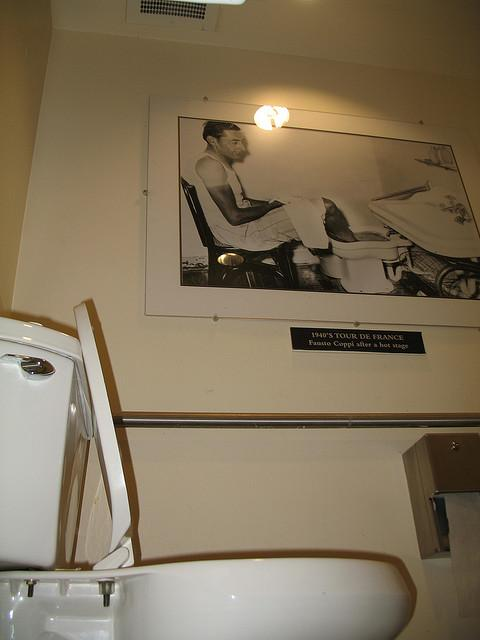What kind of athlete was the man in the black and white image most likely?

Choices:
A) footballer
B) swimmer
C) runner
D) cyclist cyclist 